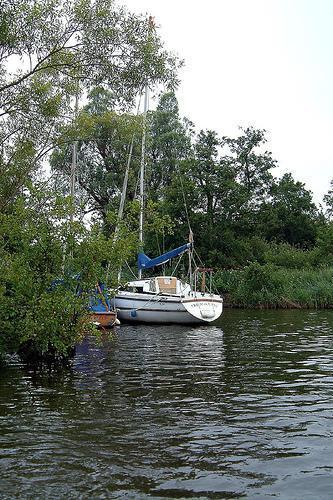How many boats on the water?
Give a very brief answer. 1. 